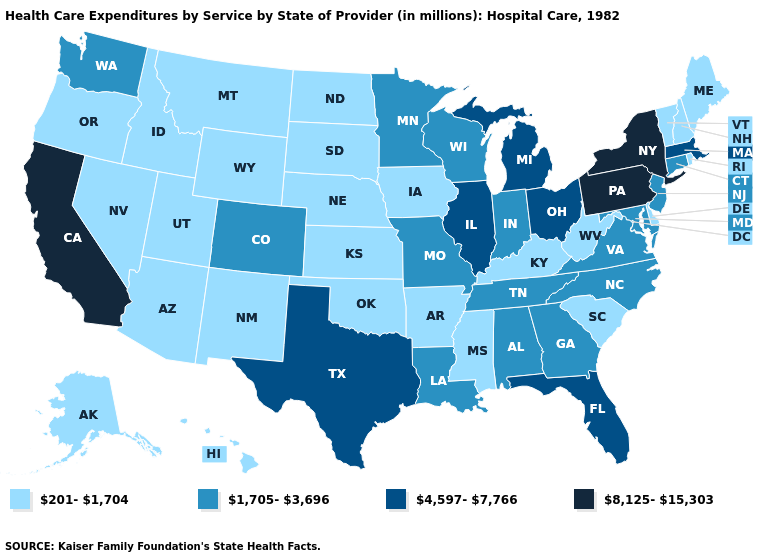What is the value of Minnesota?
Give a very brief answer. 1,705-3,696. Name the states that have a value in the range 1,705-3,696?
Be succinct. Alabama, Colorado, Connecticut, Georgia, Indiana, Louisiana, Maryland, Minnesota, Missouri, New Jersey, North Carolina, Tennessee, Virginia, Washington, Wisconsin. What is the value of California?
Write a very short answer. 8,125-15,303. Name the states that have a value in the range 201-1,704?
Keep it brief. Alaska, Arizona, Arkansas, Delaware, Hawaii, Idaho, Iowa, Kansas, Kentucky, Maine, Mississippi, Montana, Nebraska, Nevada, New Hampshire, New Mexico, North Dakota, Oklahoma, Oregon, Rhode Island, South Carolina, South Dakota, Utah, Vermont, West Virginia, Wyoming. What is the lowest value in the USA?
Short answer required. 201-1,704. What is the lowest value in states that border Illinois?
Quick response, please. 201-1,704. Name the states that have a value in the range 201-1,704?
Short answer required. Alaska, Arizona, Arkansas, Delaware, Hawaii, Idaho, Iowa, Kansas, Kentucky, Maine, Mississippi, Montana, Nebraska, Nevada, New Hampshire, New Mexico, North Dakota, Oklahoma, Oregon, Rhode Island, South Carolina, South Dakota, Utah, Vermont, West Virginia, Wyoming. Is the legend a continuous bar?
Quick response, please. No. Name the states that have a value in the range 4,597-7,766?
Write a very short answer. Florida, Illinois, Massachusetts, Michigan, Ohio, Texas. Which states have the lowest value in the USA?
Concise answer only. Alaska, Arizona, Arkansas, Delaware, Hawaii, Idaho, Iowa, Kansas, Kentucky, Maine, Mississippi, Montana, Nebraska, Nevada, New Hampshire, New Mexico, North Dakota, Oklahoma, Oregon, Rhode Island, South Carolina, South Dakota, Utah, Vermont, West Virginia, Wyoming. Does New Jersey have the lowest value in the USA?
Short answer required. No. Does Ohio have a lower value than New York?
Quick response, please. Yes. Which states have the highest value in the USA?
Keep it brief. California, New York, Pennsylvania. Does Pennsylvania have the highest value in the USA?
Answer briefly. Yes. How many symbols are there in the legend?
Answer briefly. 4. 